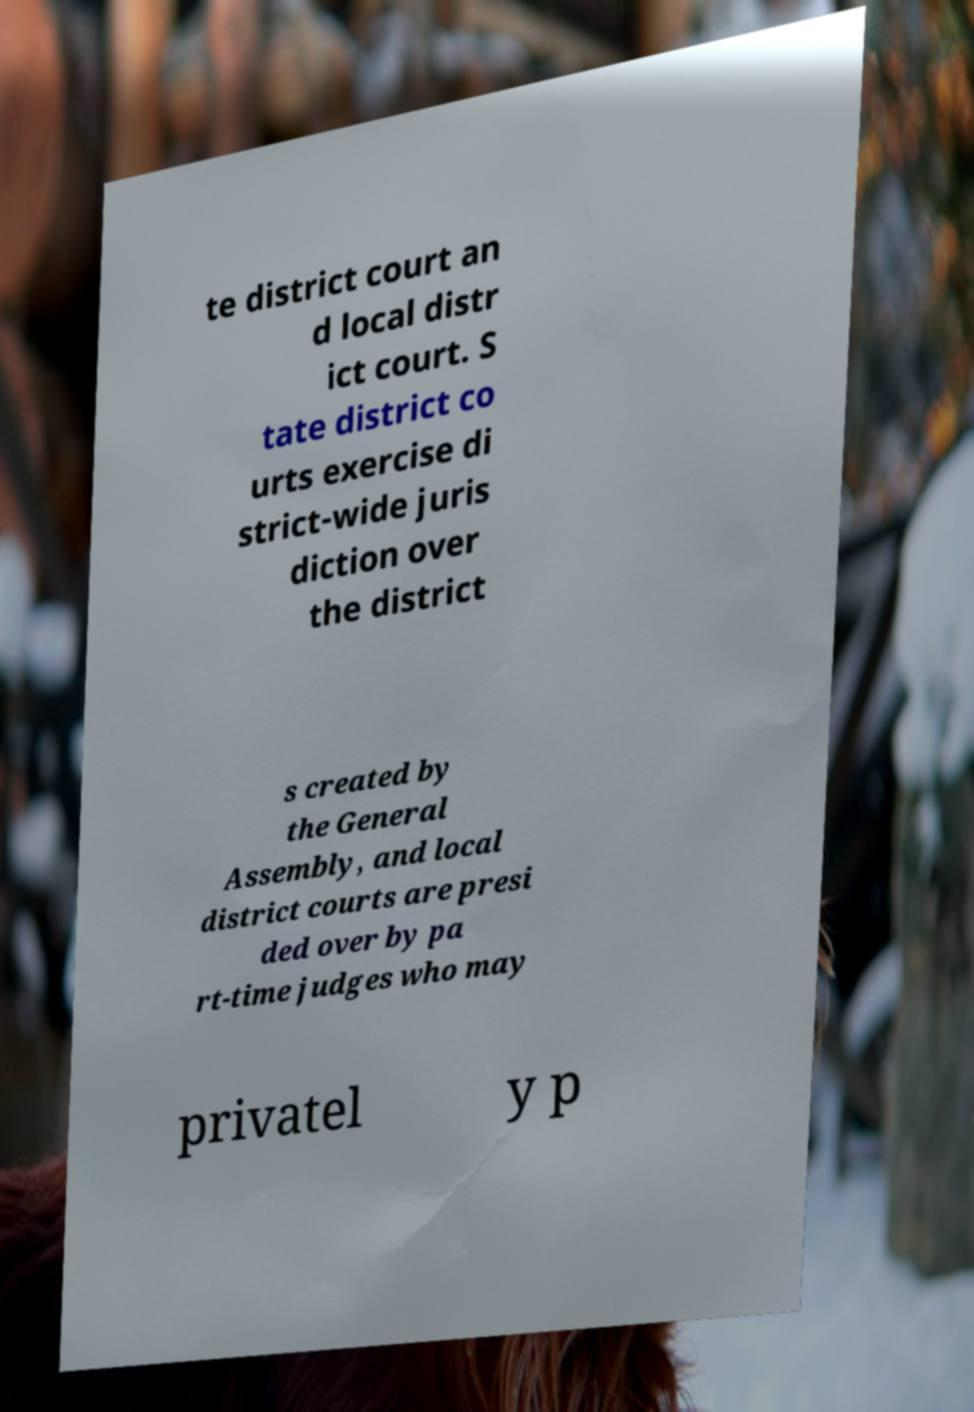Can you accurately transcribe the text from the provided image for me? te district court an d local distr ict court. S tate district co urts exercise di strict-wide juris diction over the district s created by the General Assembly, and local district courts are presi ded over by pa rt-time judges who may privatel y p 